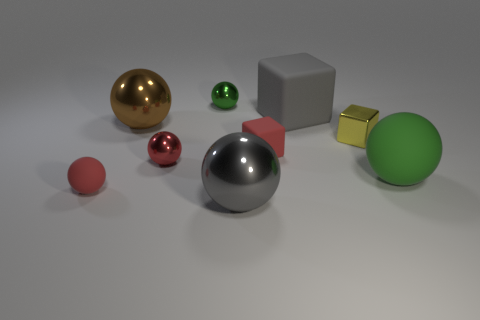Subtract all red matte cubes. How many cubes are left? 2 Subtract all red balls. How many balls are left? 4 Subtract 4 balls. How many balls are left? 2 Add 1 small shiny objects. How many objects exist? 10 Subtract all balls. How many objects are left? 3 Subtract all green blocks. Subtract all gray cylinders. How many blocks are left? 3 Subtract all red cylinders. How many gray spheres are left? 1 Subtract all small red rubber cubes. Subtract all purple matte objects. How many objects are left? 8 Add 2 matte things. How many matte things are left? 6 Add 3 tiny green metallic things. How many tiny green metallic things exist? 4 